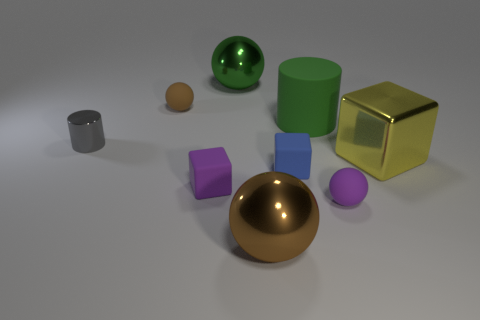Subtract all yellow blocks. Subtract all yellow cylinders. How many blocks are left? 2 Subtract all yellow cylinders. How many gray cubes are left? 0 Add 5 purples. How many big browns exist? 0 Subtract all spheres. Subtract all tiny rubber balls. How many objects are left? 3 Add 8 gray shiny objects. How many gray shiny objects are left? 9 Add 3 yellow shiny blocks. How many yellow shiny blocks exist? 4 Add 1 green metallic things. How many objects exist? 10 Subtract all yellow blocks. How many blocks are left? 2 Subtract all large green metal balls. How many balls are left? 3 Subtract 0 brown blocks. How many objects are left? 9 